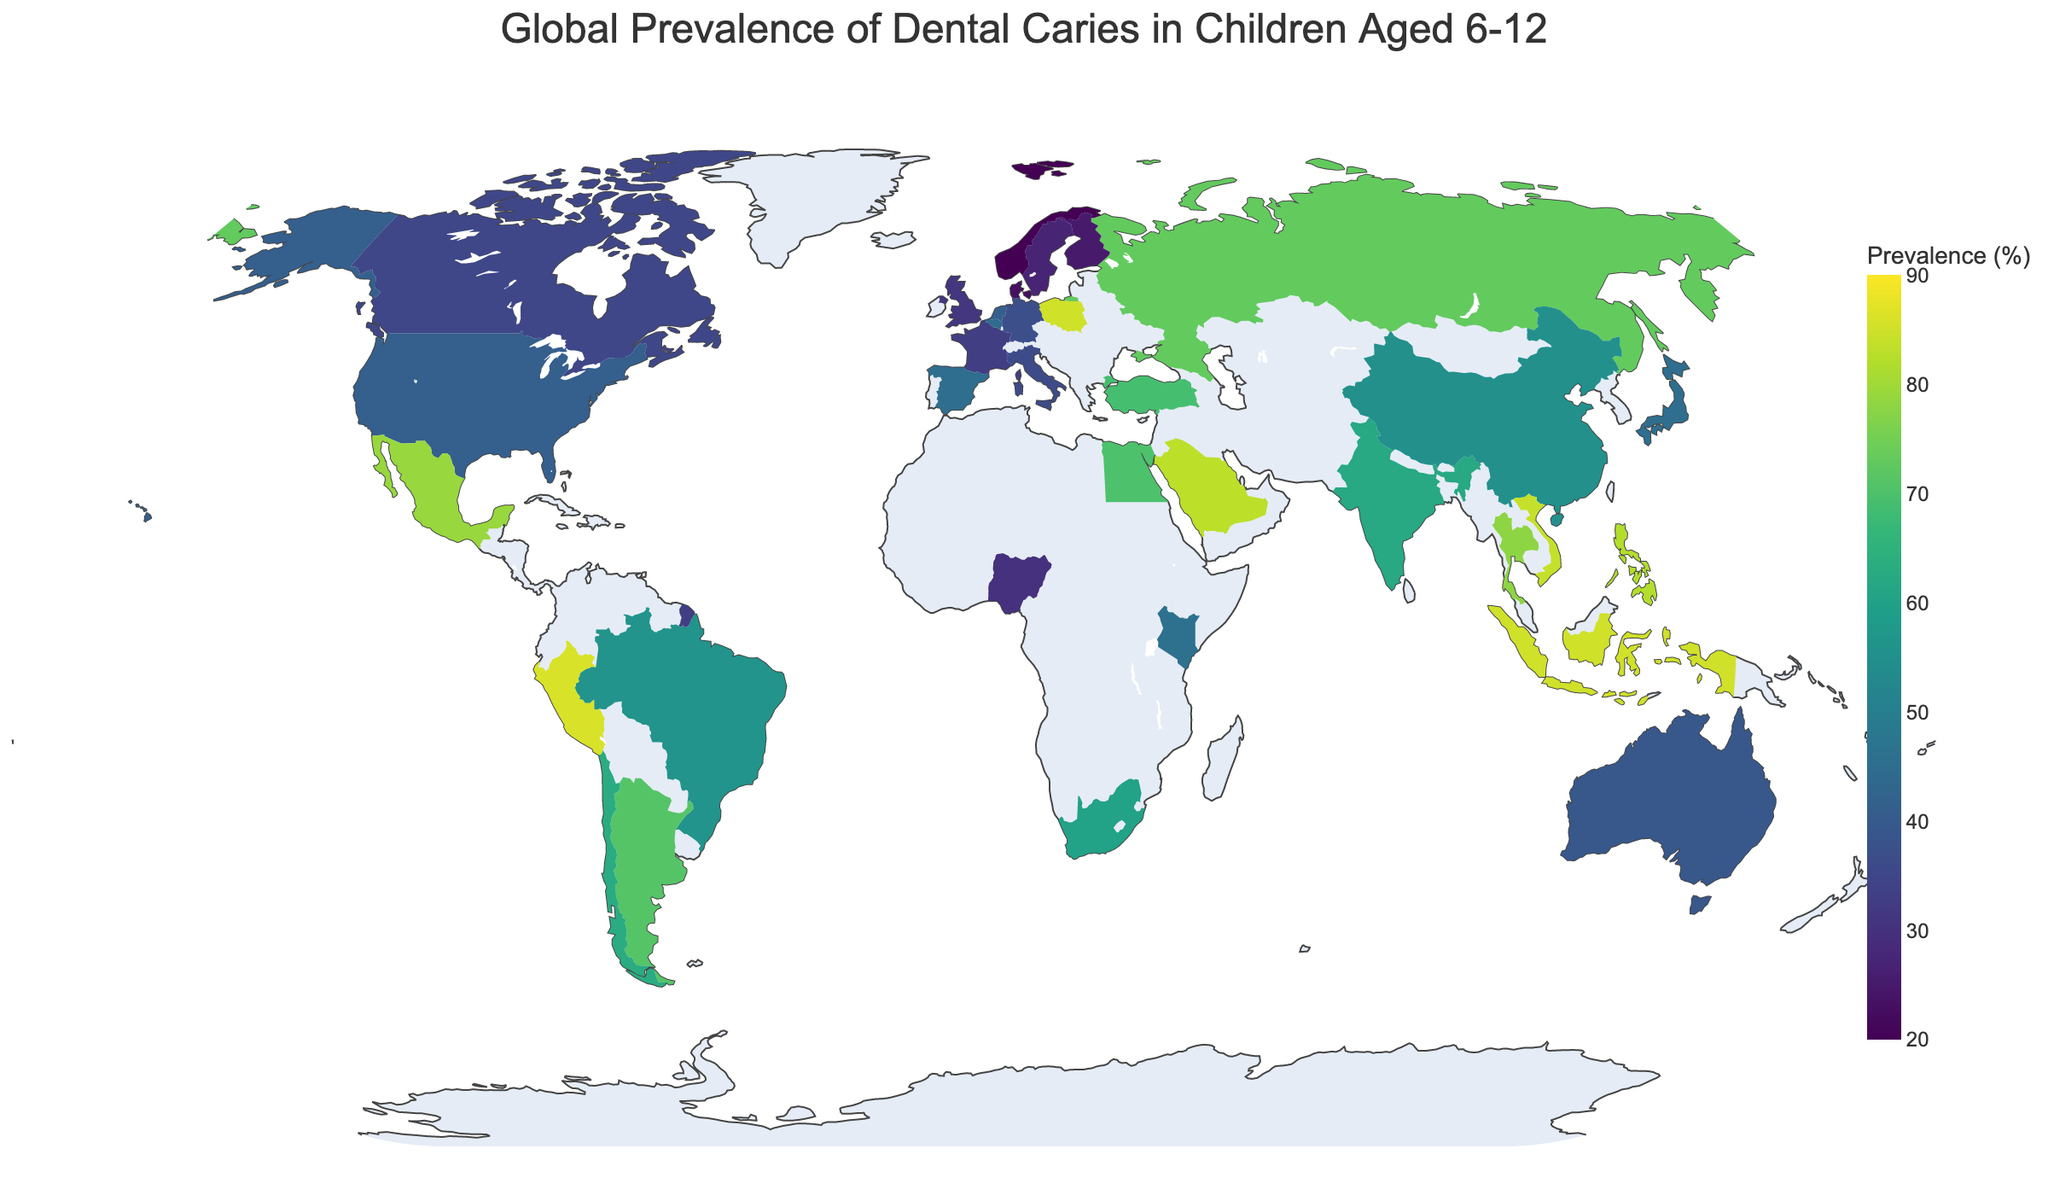What is the title of the figure? The title of the figure is displayed prominently at the top, centered. It provides a clear description of the content.
Answer: Global Prevalence of Dental Caries in Children Aged 6-12 Which country has the highest prevalence of dental caries in children aged 6-12? To find the country with the highest prevalence, look for the country shaded with the darkest color, which indicates the highest value on the color scale.
Answer: Peru Which regions have a prevalence percentage range between 20% and 30%? Check the countries shaded with the lightest colors, as they fall within the lower end of the color scale. These colors correspond to percentages between 20% and 30%.
Answer: Norway, Sweden, Finland, Denmark, Nigeria How does the prevalence in Mexico compare to the prevalence in Canada? Compare the color shades of Mexico and Canada and check their corresponding numeric prevalence percentages.
Answer: Mexico has a higher prevalence (79%) than Canada (35%) What is the average prevalence percentage of dental caries in Brazil, China, and Japan? Retrieve the prevalence percentages for Brazil (56%), China (55%), and Japan (45%). Sum these values and divide by 3.
Answer: (56 + 55 + 45) / 3 = 52 What is the color scale used in the figure? Identify the sequential color scale used to represent prevalence percentages. Look for the legend or color bar indicating the gradient.
Answer: Viridis Which countries have a prevalence percentage of 85%? Search for countries shaded with the darkest color close to the highest point on the color scale and verify with the numeric labels or tooltip.
Answer: Poland, Indonesia Is the prevalence of dental caries in children aged 6-12 higher in Russia or India? Compare the colors of Russia and India on the map and check their numeric prevalence values.
Answer: India (62%) has a lower prevalence than Russia (73%) Which country in Europe has the highest prevalence percentage and what is its value? Examine the map for European countries, focusing on shades and checking numeric values to find the highest percentage within Europe.
Answer: Poland, 85% How does the prevalence in African countries compare overall with South American countries? Look at the Africa and South America regions and compare the color shades, which represent the overall prevalence percentages. Consider the darker shades indicate higher prevalence.
Answer: South America generally shows higher prevalence (darker shades) than Africa 